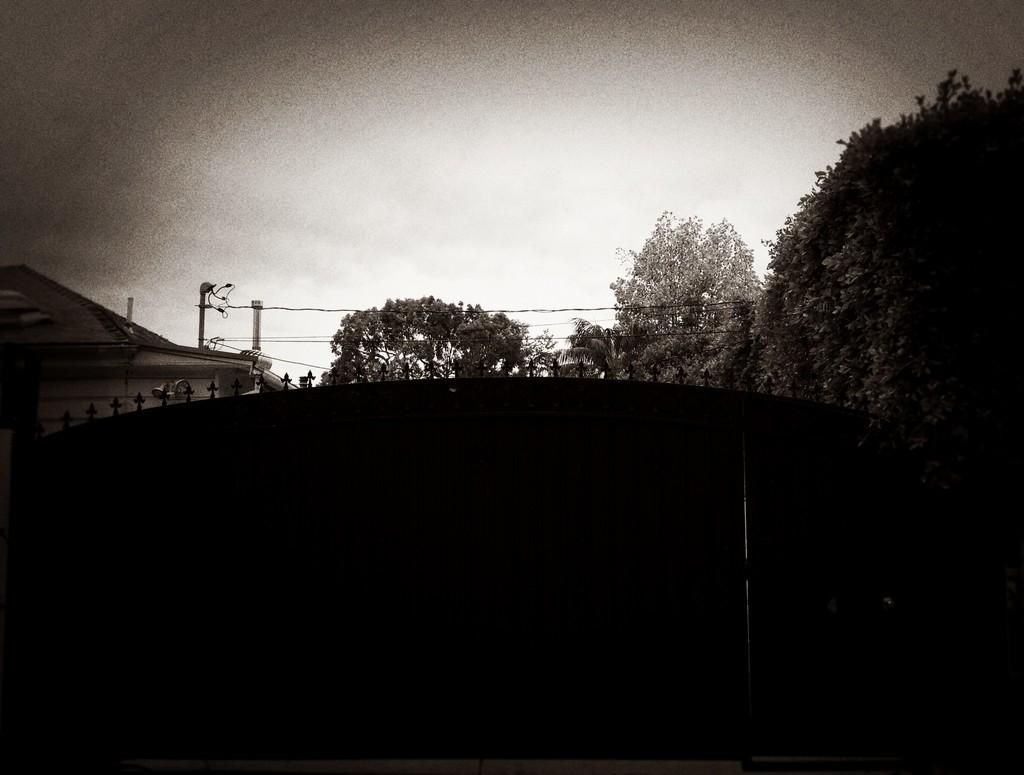What type of structure is present in the image? There is a building in the image. What type of natural elements are visible in the image? There are trees in the image. What type of man-made structures can be seen in the image? There are wires and poles in the image. What is visible in the background of the image? The sky is visible in the background of the image. Can you tell me how many cards are being used in the jail depicted in the image? There is no jail or cards present in the image. What type of credit is being offered to the people in the image? There is no credit being offered in the image. 